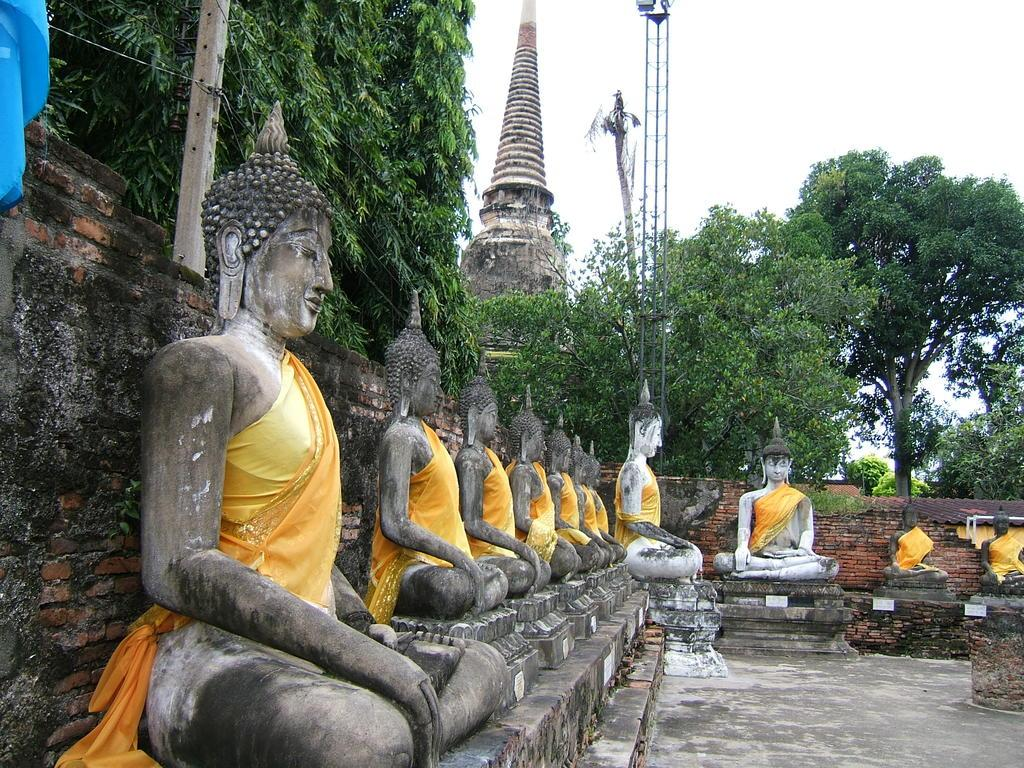What type of objects can be seen in the image? There are many sculptures in the image. What type of structure is present in the image? There is a brick wall, a building, and a tower in the image. What type of natural elements can be seen in the image? There are trees and the sky visible in the image. Can you see any boats or ships in the harbor in the image? There is no harbor or boats visible in the image. What type of iron is used to create the sculptures in the image? The sculptures in the image are not made of iron, and there is no mention of iron in the provided facts. 